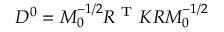Convert formula to latex. <formula><loc_0><loc_0><loc_500><loc_500>\begin{array} { r } { D ^ { 0 } = M _ { 0 } ^ { - 1 / 2 } R ^ { T } K R M _ { 0 } ^ { - 1 / 2 } } \end{array}</formula> 